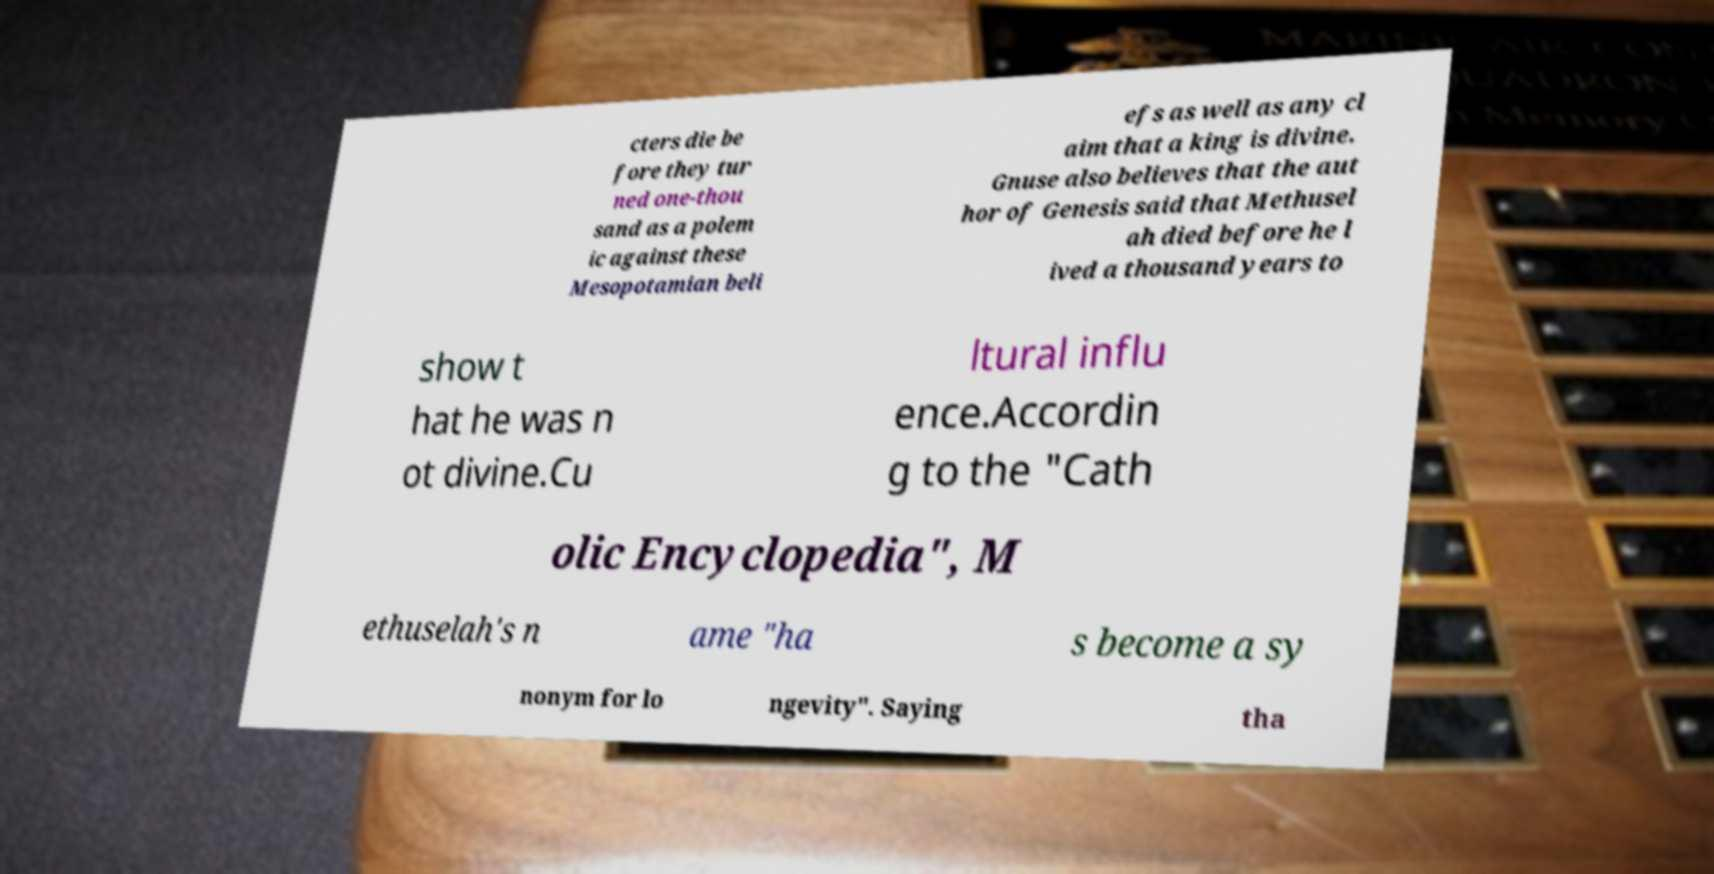Please identify and transcribe the text found in this image. cters die be fore they tur ned one-thou sand as a polem ic against these Mesopotamian beli efs as well as any cl aim that a king is divine. Gnuse also believes that the aut hor of Genesis said that Methusel ah died before he l ived a thousand years to show t hat he was n ot divine.Cu ltural influ ence.Accordin g to the "Cath olic Encyclopedia", M ethuselah's n ame "ha s become a sy nonym for lo ngevity". Saying tha 